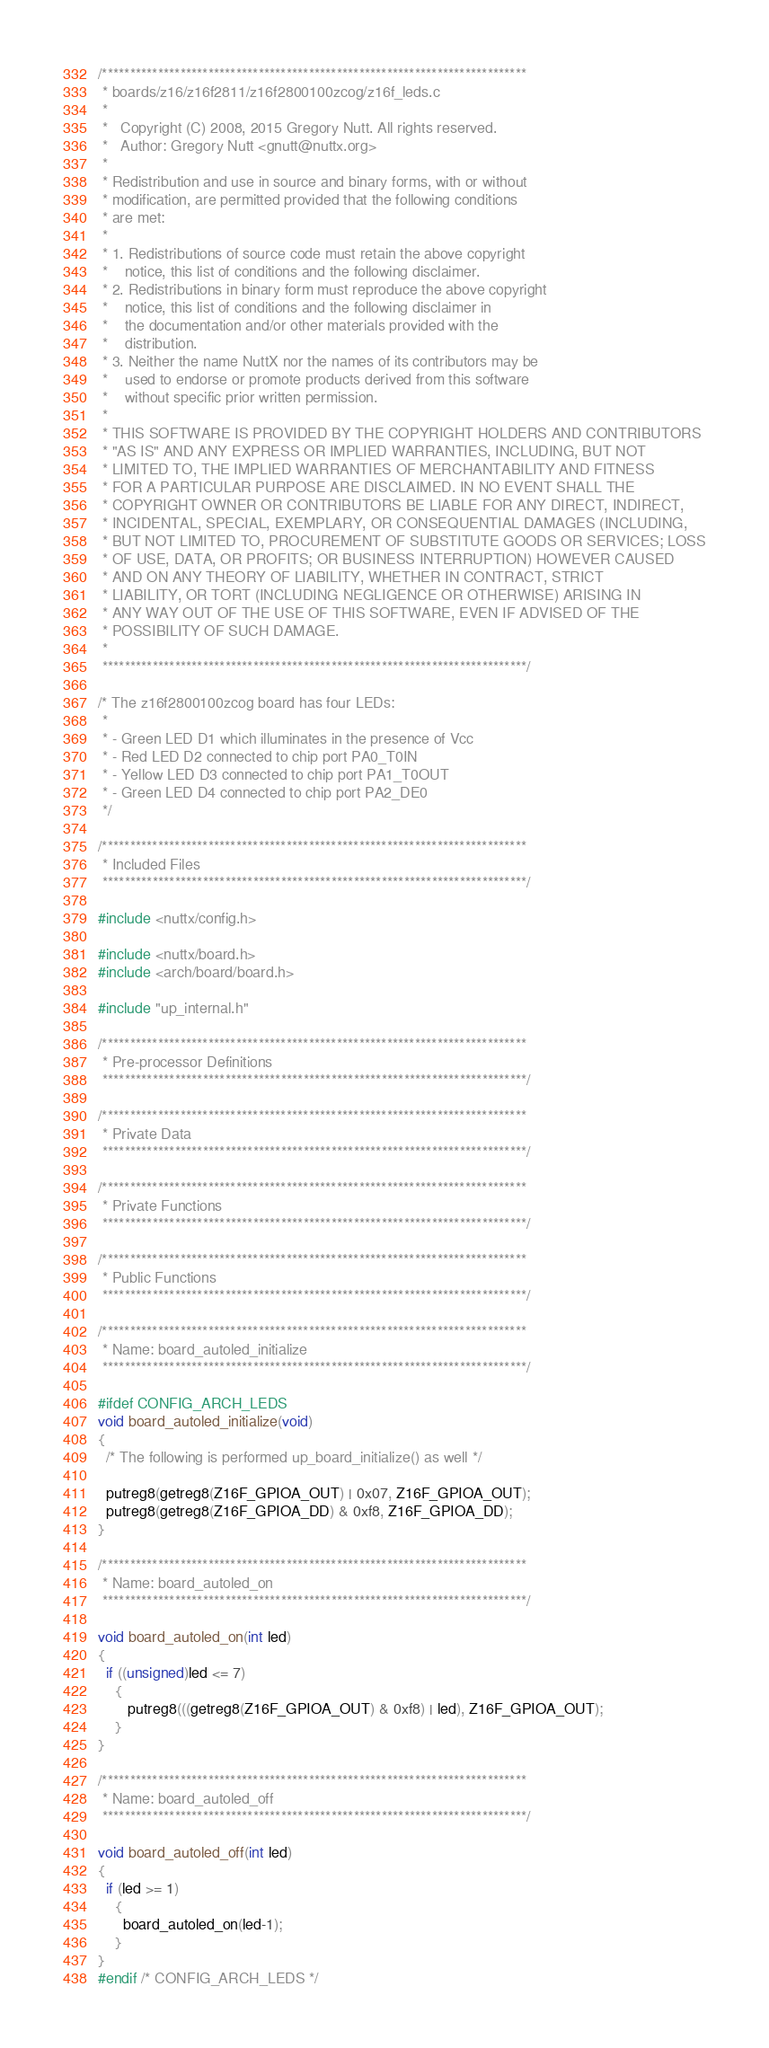<code> <loc_0><loc_0><loc_500><loc_500><_C_>/****************************************************************************
 * boards/z16/z16f2811/z16f2800100zcog/z16f_leds.c
 *
 *   Copyright (C) 2008, 2015 Gregory Nutt. All rights reserved.
 *   Author: Gregory Nutt <gnutt@nuttx.org>
 *
 * Redistribution and use in source and binary forms, with or without
 * modification, are permitted provided that the following conditions
 * are met:
 *
 * 1. Redistributions of source code must retain the above copyright
 *    notice, this list of conditions and the following disclaimer.
 * 2. Redistributions in binary form must reproduce the above copyright
 *    notice, this list of conditions and the following disclaimer in
 *    the documentation and/or other materials provided with the
 *    distribution.
 * 3. Neither the name NuttX nor the names of its contributors may be
 *    used to endorse or promote products derived from this software
 *    without specific prior written permission.
 *
 * THIS SOFTWARE IS PROVIDED BY THE COPYRIGHT HOLDERS AND CONTRIBUTORS
 * "AS IS" AND ANY EXPRESS OR IMPLIED WARRANTIES, INCLUDING, BUT NOT
 * LIMITED TO, THE IMPLIED WARRANTIES OF MERCHANTABILITY AND FITNESS
 * FOR A PARTICULAR PURPOSE ARE DISCLAIMED. IN NO EVENT SHALL THE
 * COPYRIGHT OWNER OR CONTRIBUTORS BE LIABLE FOR ANY DIRECT, INDIRECT,
 * INCIDENTAL, SPECIAL, EXEMPLARY, OR CONSEQUENTIAL DAMAGES (INCLUDING,
 * BUT NOT LIMITED TO, PROCUREMENT OF SUBSTITUTE GOODS OR SERVICES; LOSS
 * OF USE, DATA, OR PROFITS; OR BUSINESS INTERRUPTION) HOWEVER CAUSED
 * AND ON ANY THEORY OF LIABILITY, WHETHER IN CONTRACT, STRICT
 * LIABILITY, OR TORT (INCLUDING NEGLIGENCE OR OTHERWISE) ARISING IN
 * ANY WAY OUT OF THE USE OF THIS SOFTWARE, EVEN IF ADVISED OF THE
 * POSSIBILITY OF SUCH DAMAGE.
 *
 ****************************************************************************/

/* The z16f2800100zcog board has four LEDs:
 *
 * - Green LED D1 which illuminates in the presence of Vcc
 * - Red LED D2 connected to chip port PA0_T0IN
 * - Yellow LED D3 connected to chip port PA1_T0OUT
 * - Green LED D4 connected to chip port PA2_DE0
 */

/****************************************************************************
 * Included Files
 ****************************************************************************/

#include <nuttx/config.h>

#include <nuttx/board.h>
#include <arch/board/board.h>

#include "up_internal.h"

/****************************************************************************
 * Pre-processor Definitions
 ****************************************************************************/

/****************************************************************************
 * Private Data
 ****************************************************************************/

/****************************************************************************
 * Private Functions
 ****************************************************************************/

/****************************************************************************
 * Public Functions
 ****************************************************************************/

/****************************************************************************
 * Name: board_autoled_initialize
 ****************************************************************************/

#ifdef CONFIG_ARCH_LEDS
void board_autoled_initialize(void)
{
  /* The following is performed up_board_initialize() as well */

  putreg8(getreg8(Z16F_GPIOA_OUT) | 0x07, Z16F_GPIOA_OUT);
  putreg8(getreg8(Z16F_GPIOA_DD) & 0xf8, Z16F_GPIOA_DD);
}

/****************************************************************************
 * Name: board_autoled_on
 ****************************************************************************/

void board_autoled_on(int led)
{
  if ((unsigned)led <= 7)
    {
       putreg8(((getreg8(Z16F_GPIOA_OUT) & 0xf8) | led), Z16F_GPIOA_OUT);
    }
}

/****************************************************************************
 * Name: board_autoled_off
 ****************************************************************************/

void board_autoled_off(int led)
{
  if (led >= 1)
    {
      board_autoled_on(led-1);
    }
}
#endif /* CONFIG_ARCH_LEDS */
</code> 